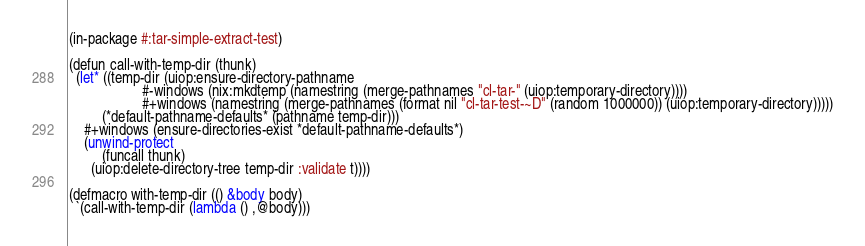<code> <loc_0><loc_0><loc_500><loc_500><_Lisp_>(in-package #:tar-simple-extract-test)

(defun call-with-temp-dir (thunk)
  (let* ((temp-dir (uiop:ensure-directory-pathname
                    #-windows (nix:mkdtemp (namestring (merge-pathnames "cl-tar-" (uiop:temporary-directory))))
                    #+windows (namestring (merge-pathnames (format nil "cl-tar-test-~D" (random 1000000)) (uiop:temporary-directory)))))
         (*default-pathname-defaults* (pathname temp-dir)))
    #+windows (ensure-directories-exist *default-pathname-defaults*)
    (unwind-protect
         (funcall thunk)
      (uiop:delete-directory-tree temp-dir :validate t))))

(defmacro with-temp-dir (() &body body)
  `(call-with-temp-dir (lambda () ,@body)))
</code> 